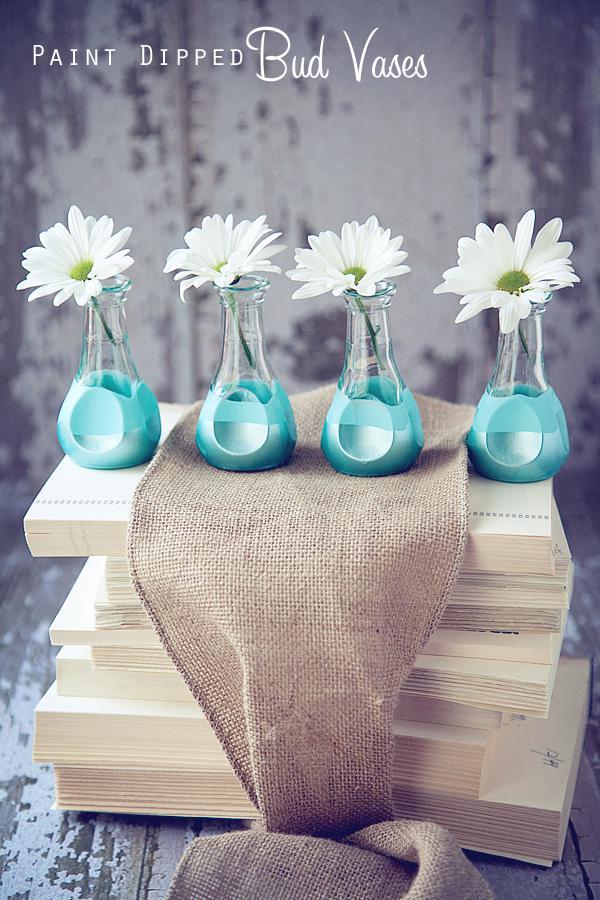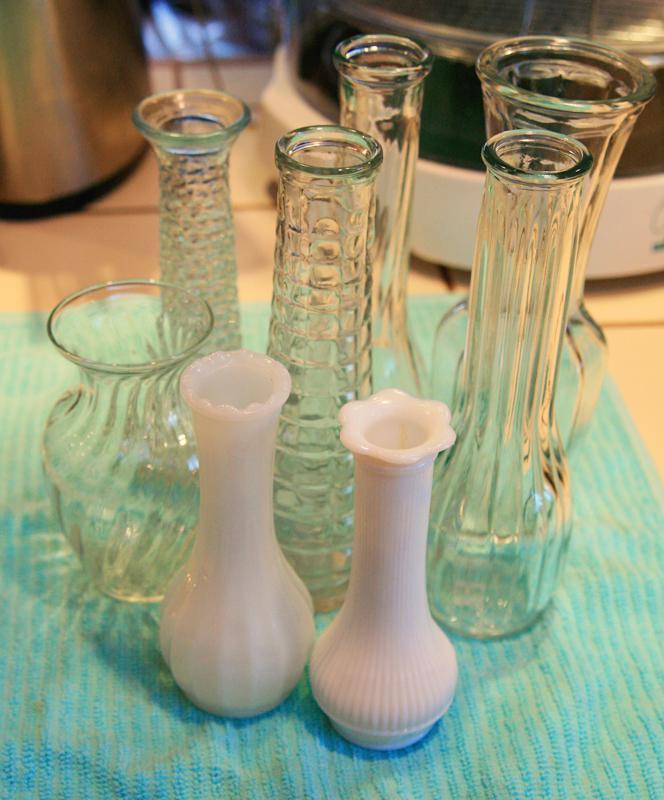The first image is the image on the left, the second image is the image on the right. Given the left and right images, does the statement "At least one vase appears bright blue." hold true? Answer yes or no. Yes. 